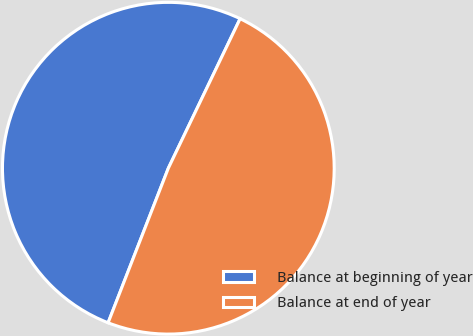Convert chart. <chart><loc_0><loc_0><loc_500><loc_500><pie_chart><fcel>Balance at beginning of year<fcel>Balance at end of year<nl><fcel>51.21%<fcel>48.79%<nl></chart> 